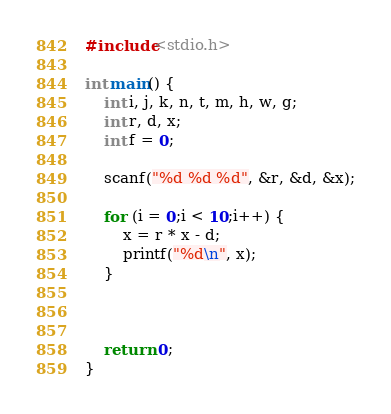<code> <loc_0><loc_0><loc_500><loc_500><_C_>#include<stdio.h>

int main() {
	int i, j, k, n, t, m, h, w, g;
	int r, d, x;
	int f = 0;

	scanf("%d %d %d", &r, &d, &x);

	for (i = 0;i < 10;i++) {
		x = r * x - d;
		printf("%d\n", x);
	}



	return 0;
}</code> 